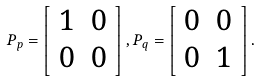<formula> <loc_0><loc_0><loc_500><loc_500>P _ { p } = \left [ \begin{array} [ c ] { c c } 1 & 0 \\ 0 & 0 \end{array} \right ] , P _ { q } = \left [ \begin{array} [ c ] { c c } 0 & 0 \\ 0 & 1 \end{array} \right ] .</formula> 